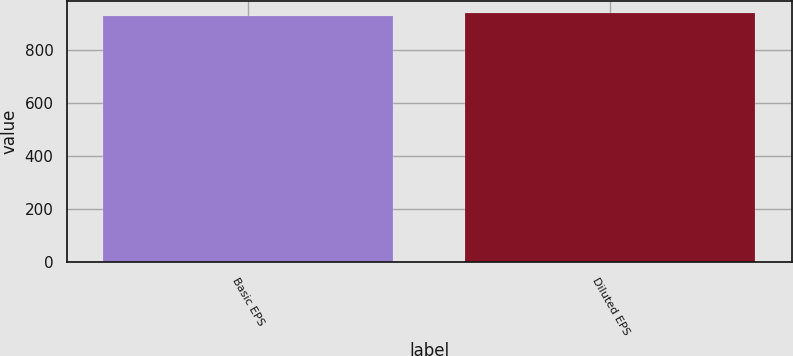Convert chart to OTSL. <chart><loc_0><loc_0><loc_500><loc_500><bar_chart><fcel>Basic EPS<fcel>Diluted EPS<nl><fcel>930.8<fcel>939.9<nl></chart> 